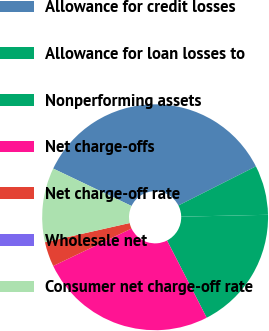Convert chart. <chart><loc_0><loc_0><loc_500><loc_500><pie_chart><fcel>Allowance for credit losses<fcel>Allowance for loan losses to<fcel>Nonperforming assets<fcel>Net charge-offs<fcel>Net charge-off rate<fcel>Wholesale net<fcel>Consumer net charge-off rate<nl><fcel>35.46%<fcel>7.09%<fcel>17.8%<fcel>25.45%<fcel>3.55%<fcel>0.0%<fcel>10.64%<nl></chart> 